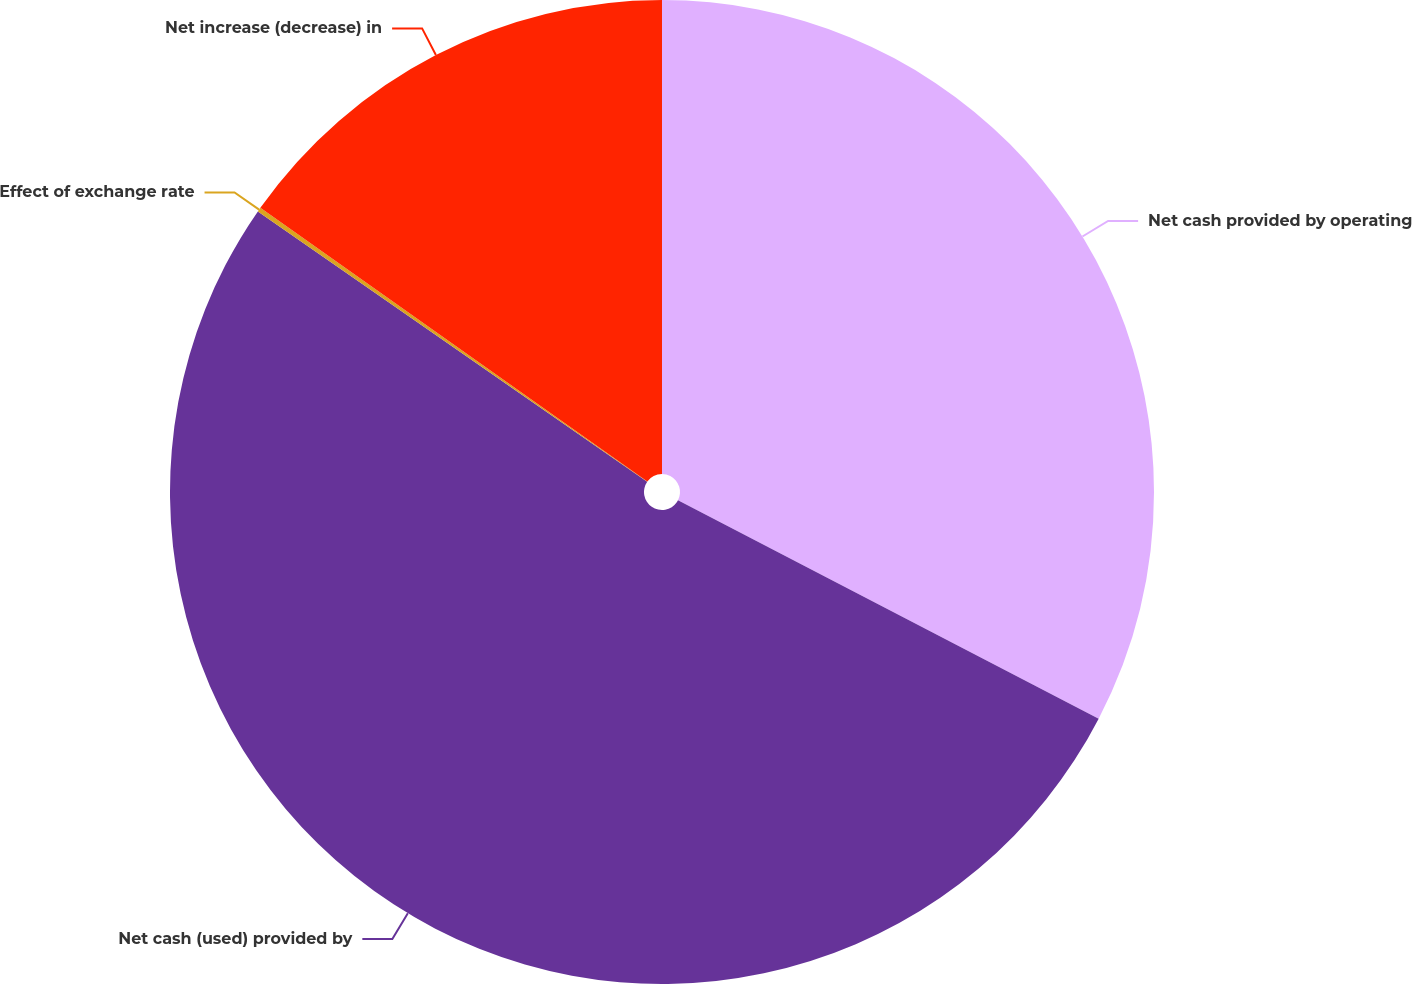Convert chart to OTSL. <chart><loc_0><loc_0><loc_500><loc_500><pie_chart><fcel>Net cash provided by operating<fcel>Net cash (used) provided by<fcel>Effect of exchange rate<fcel>Net increase (decrease) in<nl><fcel>32.62%<fcel>52.04%<fcel>0.14%<fcel>15.2%<nl></chart> 